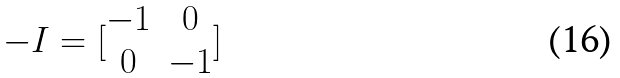Convert formula to latex. <formula><loc_0><loc_0><loc_500><loc_500>- I = [ \begin{matrix} - 1 & 0 \\ 0 & - 1 \end{matrix} ]</formula> 